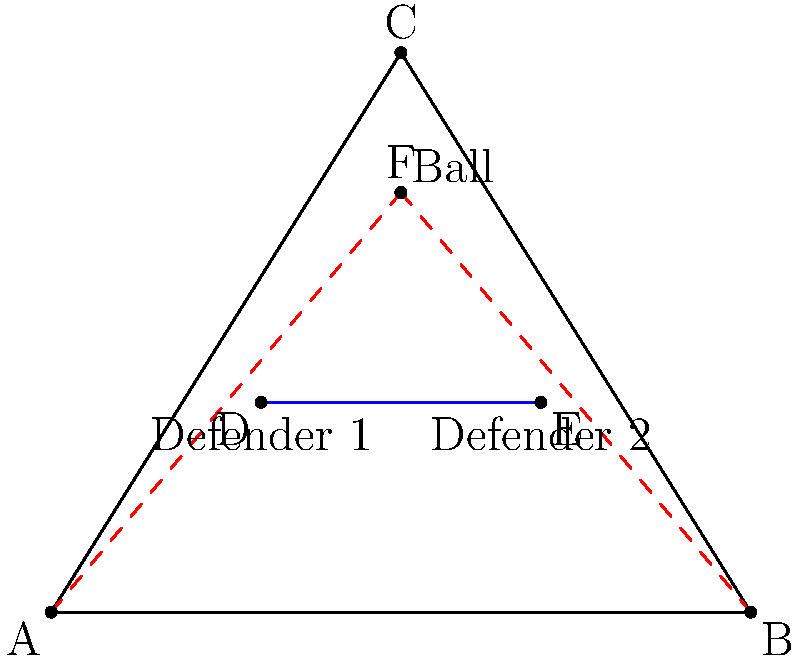In a crucial game against Nevada, Utah State's point guard needs to pass the ball to the teammate at point C, avoiding two defenders at points D and E. Given the current position of the ball at point F, which path should the ball take to safely reach the teammate: AFB or BFC? To determine the safest path for the ball, we need to consider the positions of the defenders and the space available for the pass. Let's analyze this step-by-step:

1. The ball is currently at point F, above both defenders.
2. The two defenders are positioned at points D and E, forming a line between them.
3. The teammate is positioned at point C, the apex of the triangle.
4. We have two potential paths: AFB and BFC.

5. Path AFB analysis:
   - This path goes from F to A, then to B.
   - It passes behind Defender 1 (D) but in front of Defender 2 (E).
   - The ball would need to travel a longer distance and make a sharp turn at A.

6. Path BFC analysis:
   - This path goes from F to B, then to C.
   - It passes behind both defenders (D and E).
   - The ball travels a shorter distance and has a more direct route to the teammate.

7. Considering the 2005-06 Utah State Aggies' style of play, which often emphasized efficient passing and ball movement, the safer and more efficient option would be the path that minimizes risk and provides a clearer passing lane.

Given these factors, the path BFC is the safer and more efficient option. It keeps the ball away from both defenders, provides a more direct route to the teammate, and aligns with the Aggies' strategic approach to ball movement.
Answer: BFC 